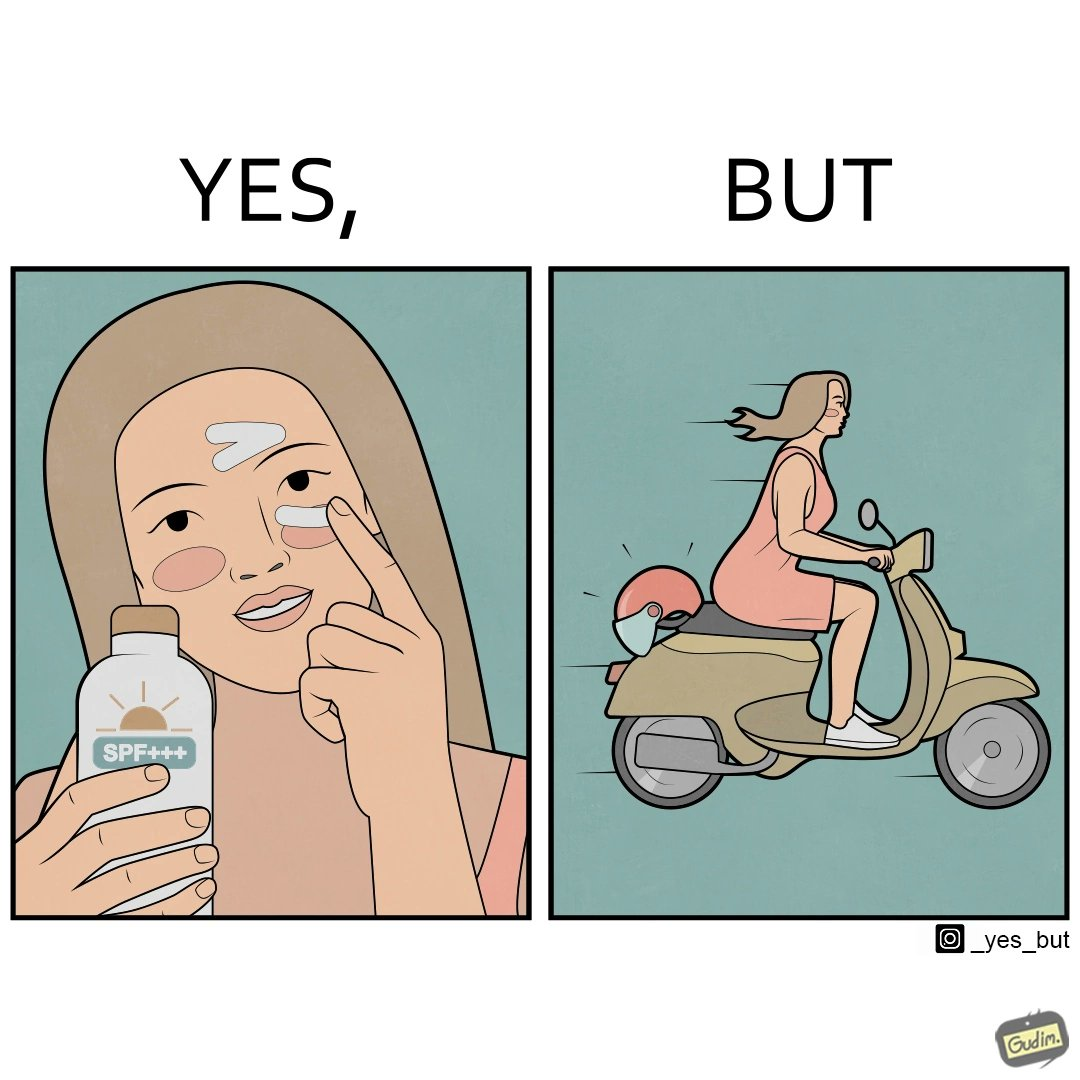Describe the satirical element in this image. The image is funny because while the woman is concerned about protection from the sun rays, she is not concerned about her safety while riding a scooter. 